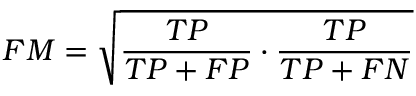Convert formula to latex. <formula><loc_0><loc_0><loc_500><loc_500>F M = { \sqrt { { \frac { T P } { T P + F P } } \cdot { \frac { T P } { T P + F N } } } }</formula> 